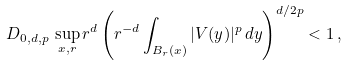<formula> <loc_0><loc_0><loc_500><loc_500>D _ { 0 , d , p } \, \sup _ { x , r } r ^ { d } \left ( r ^ { - d } \int _ { B _ { r } ( x ) } | V ( y ) | ^ { p } \, d y \right ) ^ { d / 2 p } < 1 \, ,</formula> 